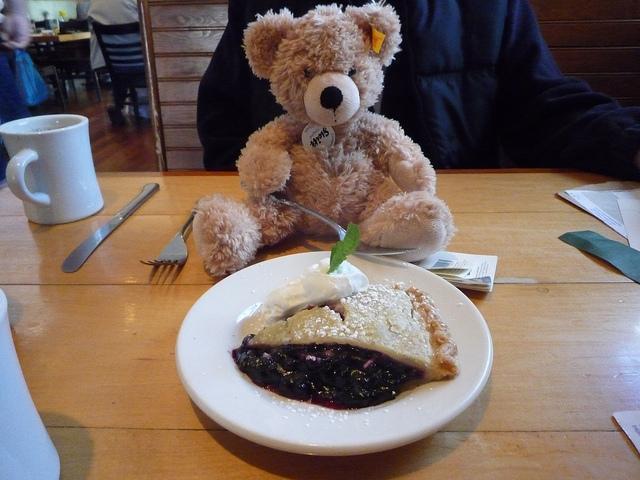Is this affirmation: "The dining table is under the teddy bear." correct?
Answer yes or no. Yes. 